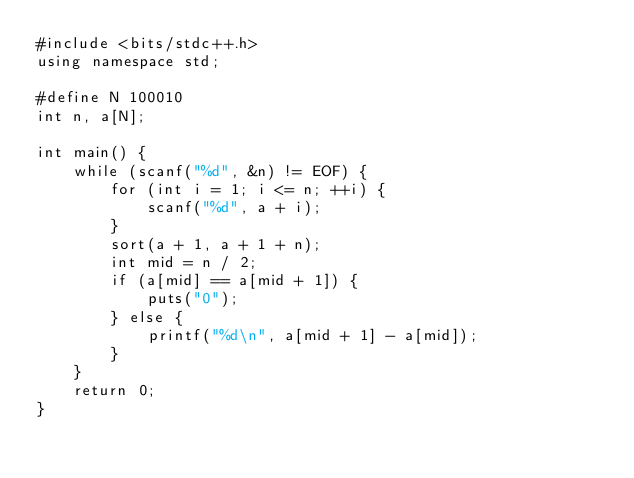Convert code to text. <code><loc_0><loc_0><loc_500><loc_500><_C++_>#include <bits/stdc++.h>
using namespace std;
 
#define N 100010
int n, a[N];
 
int main() {
    while (scanf("%d", &n) != EOF) {
        for (int i = 1; i <= n; ++i) {
            scanf("%d", a + i);
        }
        sort(a + 1, a + 1 + n);
        int mid = n / 2;
        if (a[mid] == a[mid + 1]) {
            puts("0");
        } else {
            printf("%d\n", a[mid + 1] - a[mid]);
        }
    }
    return 0;
}</code> 